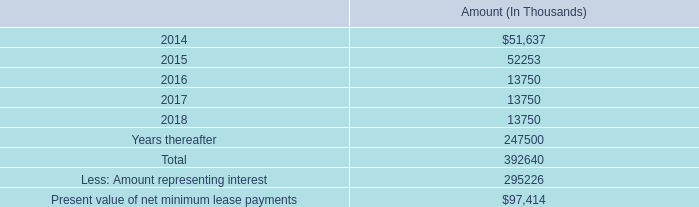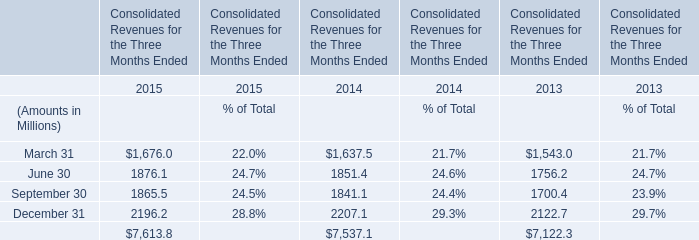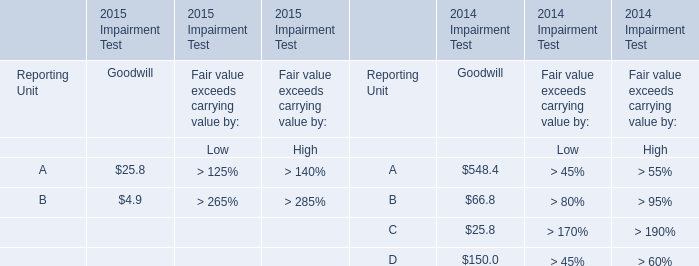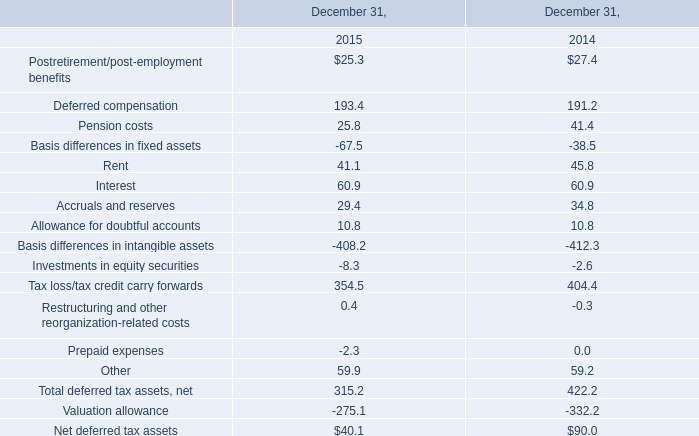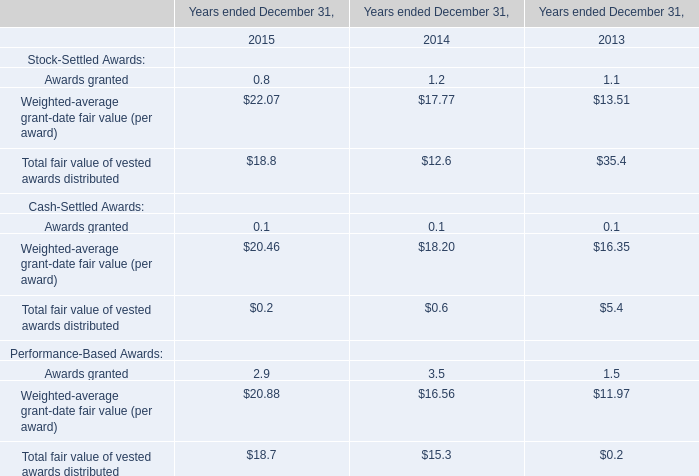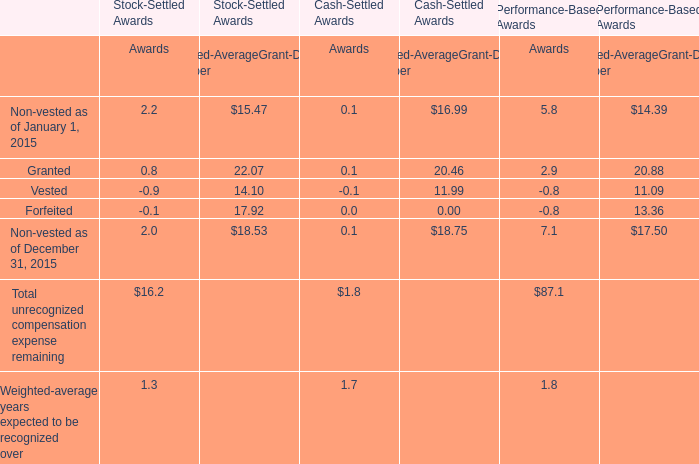What's the current growth rate of the Total fair value of vested awards distributed for Stock-Settled Awards? 
Computations: ((18.8 - 12.6) / 12.6)
Answer: 0.49206. 